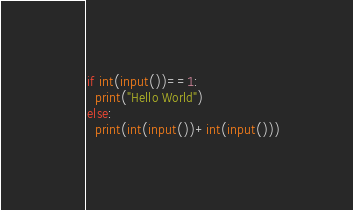Convert code to text. <code><loc_0><loc_0><loc_500><loc_500><_Python_>if int(input())==1:
  print("Hello World")
else:
  print(int(input())+int(input()))</code> 